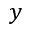Convert formula to latex. <formula><loc_0><loc_0><loc_500><loc_500>y</formula> 